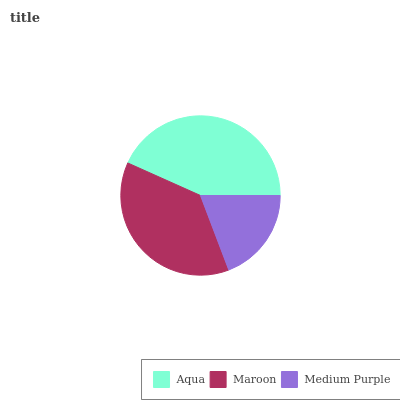Is Medium Purple the minimum?
Answer yes or no. Yes. Is Aqua the maximum?
Answer yes or no. Yes. Is Maroon the minimum?
Answer yes or no. No. Is Maroon the maximum?
Answer yes or no. No. Is Aqua greater than Maroon?
Answer yes or no. Yes. Is Maroon less than Aqua?
Answer yes or no. Yes. Is Maroon greater than Aqua?
Answer yes or no. No. Is Aqua less than Maroon?
Answer yes or no. No. Is Maroon the high median?
Answer yes or no. Yes. Is Maroon the low median?
Answer yes or no. Yes. Is Aqua the high median?
Answer yes or no. No. Is Medium Purple the low median?
Answer yes or no. No. 